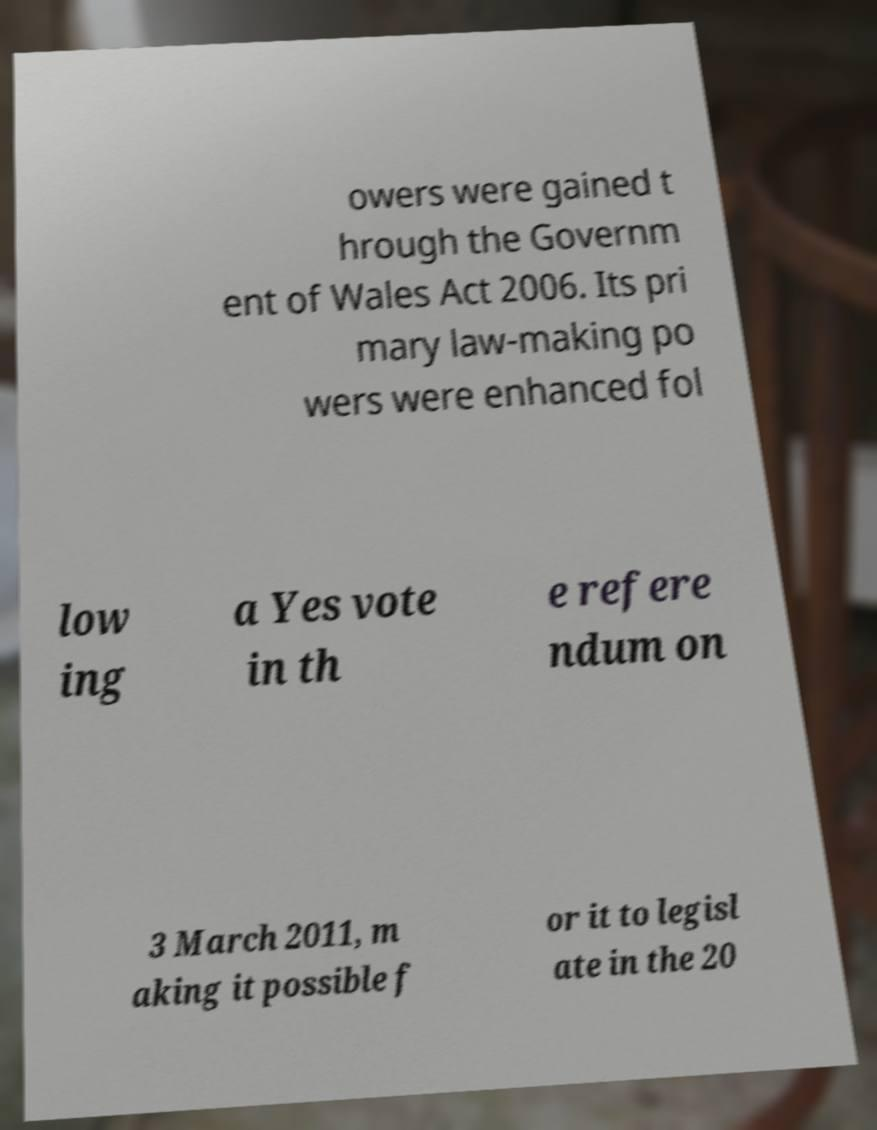Can you read and provide the text displayed in the image?This photo seems to have some interesting text. Can you extract and type it out for me? owers were gained t hrough the Governm ent of Wales Act 2006. Its pri mary law-making po wers were enhanced fol low ing a Yes vote in th e refere ndum on 3 March 2011, m aking it possible f or it to legisl ate in the 20 